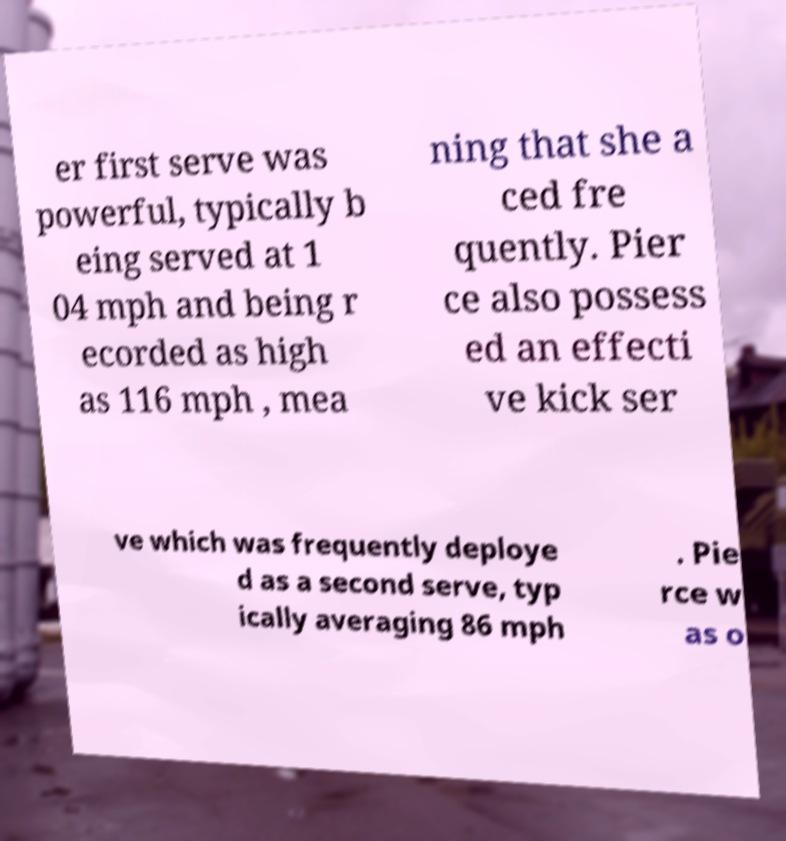There's text embedded in this image that I need extracted. Can you transcribe it verbatim? er first serve was powerful, typically b eing served at 1 04 mph and being r ecorded as high as 116 mph , mea ning that she a ced fre quently. Pier ce also possess ed an effecti ve kick ser ve which was frequently deploye d as a second serve, typ ically averaging 86 mph . Pie rce w as o 